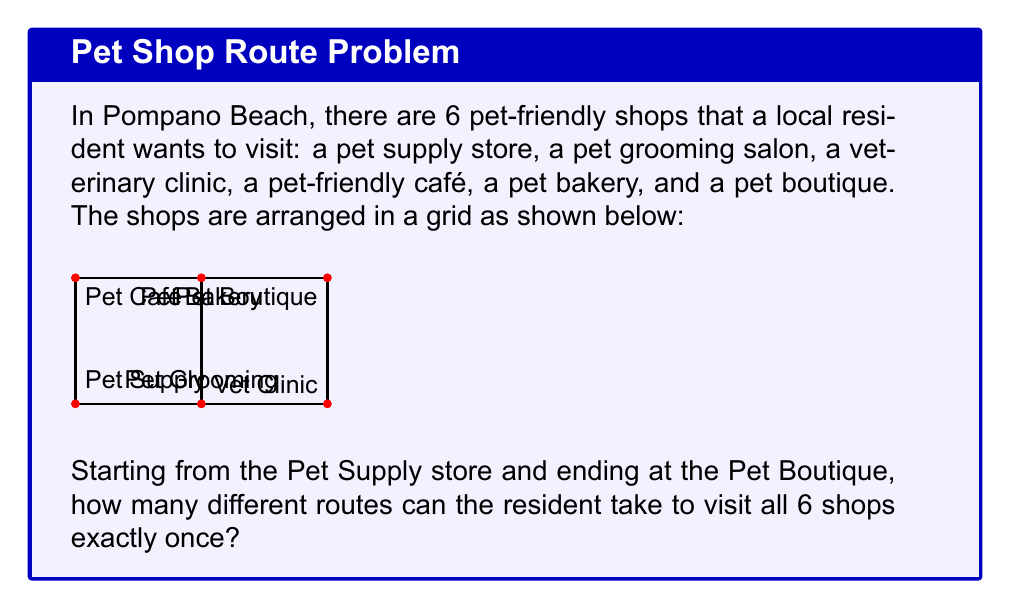Teach me how to tackle this problem. Let's approach this step-by-step:

1) First, we need to recognize that this is a path-counting problem on a graph. We're looking for the number of Hamiltonian paths from the Pet Supply store to the Pet Boutique.

2) In this case, we can use the concept of permutations. We need to count the number of ways to arrange the 4 intermediate stops (Pet Grooming, Vet Clinic, Pet Café, and Pet Bakery) between the fixed start and end points.

3) The number of permutations of 4 distinct objects is given by:

   $$4! = 4 \times 3 \times 2 \times 1 = 24$$

4) However, not all of these permutations are valid paths in our grid. We need to eliminate the impossible routes.

5) Looking at the grid, we can see that:
   - The Pet Grooming shop must be visited before the Vet Clinic
   - The Pet Café must be visited before the Pet Bakery

6) For each of these constraints, half of the permutations will be invalid. Since these constraints are independent, we need to divide our total by 2 twice:

   $$\text{Number of valid routes} = \frac{24}{2 \times 2} = 6$$

7) Therefore, there are 6 different valid routes to visit all the shops.
Answer: 6 routes 